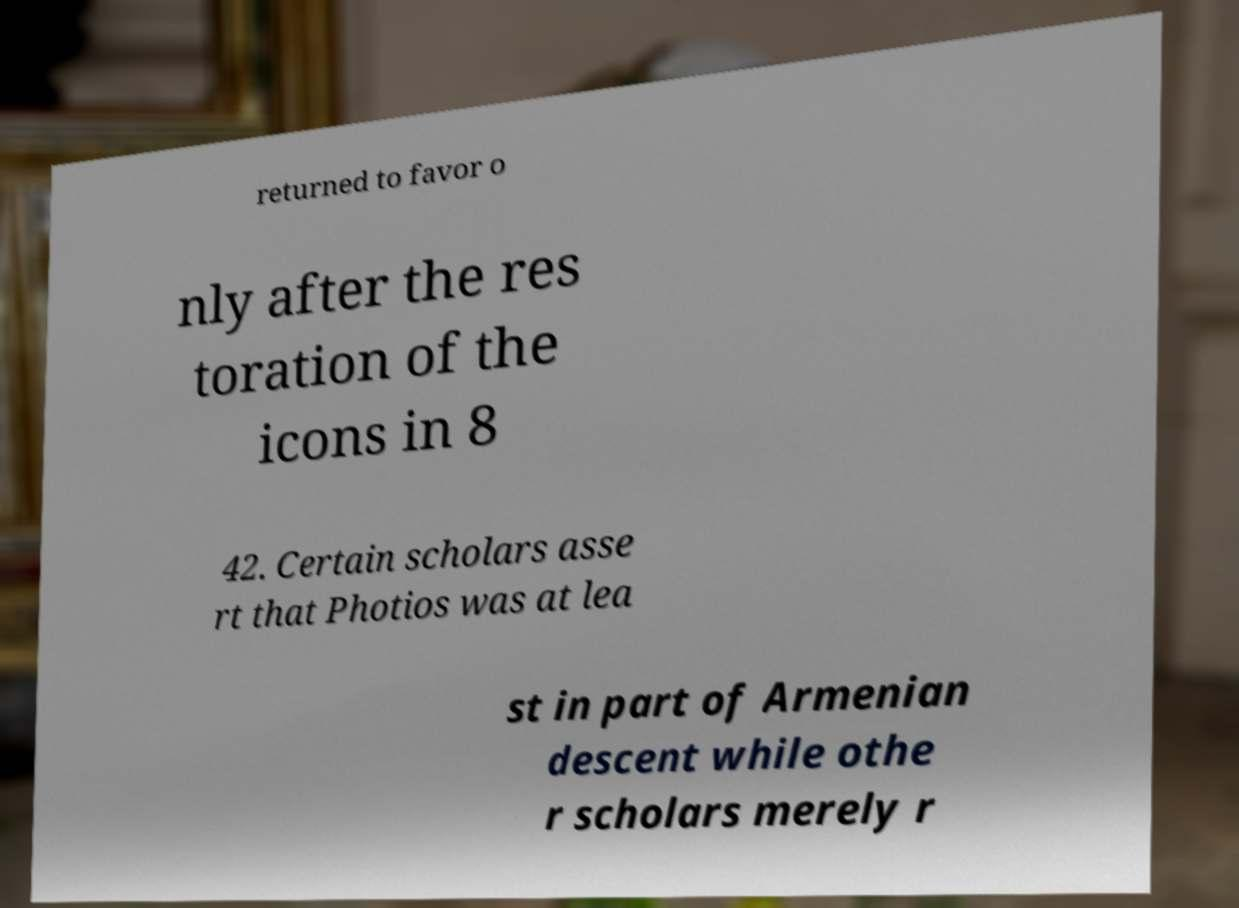Please read and relay the text visible in this image. What does it say? returned to favor o nly after the res toration of the icons in 8 42. Certain scholars asse rt that Photios was at lea st in part of Armenian descent while othe r scholars merely r 